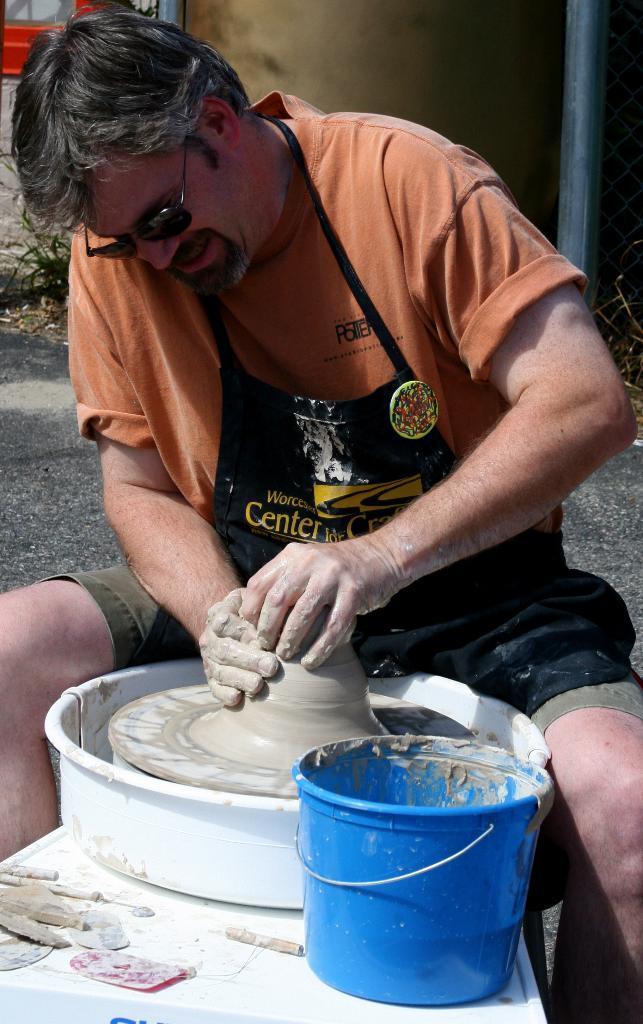Could you give a brief overview of what you see in this image? This image is taken outdoors. In the middle of the image a man is sitting on the stool and he is making a pot with clay on the machine. There is a bucket with clay. In the background there is a road and a wall. 